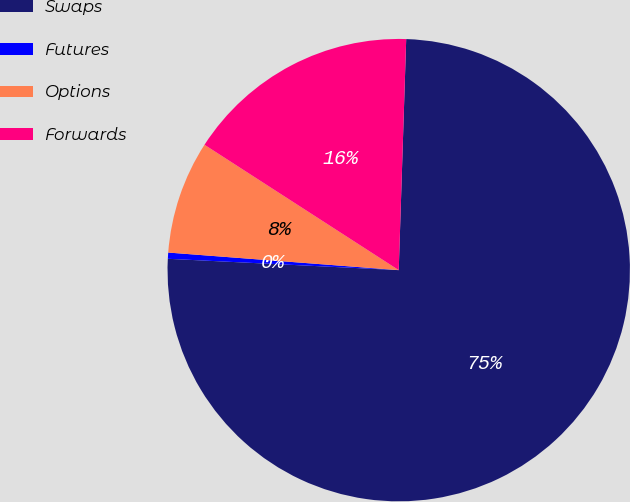Convert chart to OTSL. <chart><loc_0><loc_0><loc_500><loc_500><pie_chart><fcel>Swaps<fcel>Futures<fcel>Options<fcel>Forwards<nl><fcel>75.26%<fcel>0.43%<fcel>7.91%<fcel>16.39%<nl></chart> 